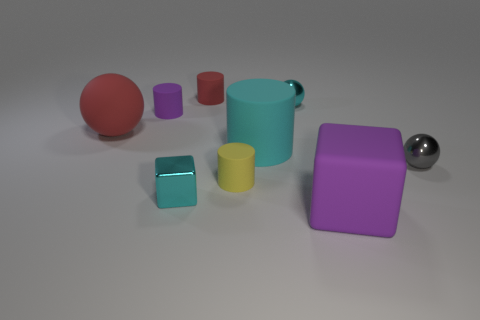Subtract all red cylinders. How many cylinders are left? 3 Subtract all blocks. How many objects are left? 7 Subtract all cyan blocks. How many blocks are left? 1 Subtract 1 cyan cylinders. How many objects are left? 8 Subtract 1 cylinders. How many cylinders are left? 3 Subtract all blue spheres. Subtract all yellow cylinders. How many spheres are left? 3 Subtract all yellow spheres. How many purple blocks are left? 1 Subtract all yellow matte cylinders. Subtract all tiny purple things. How many objects are left? 7 Add 3 tiny yellow rubber cylinders. How many tiny yellow rubber cylinders are left? 4 Add 5 purple rubber things. How many purple rubber things exist? 7 